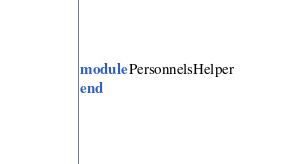<code> <loc_0><loc_0><loc_500><loc_500><_Ruby_>module PersonnelsHelper
end
</code> 